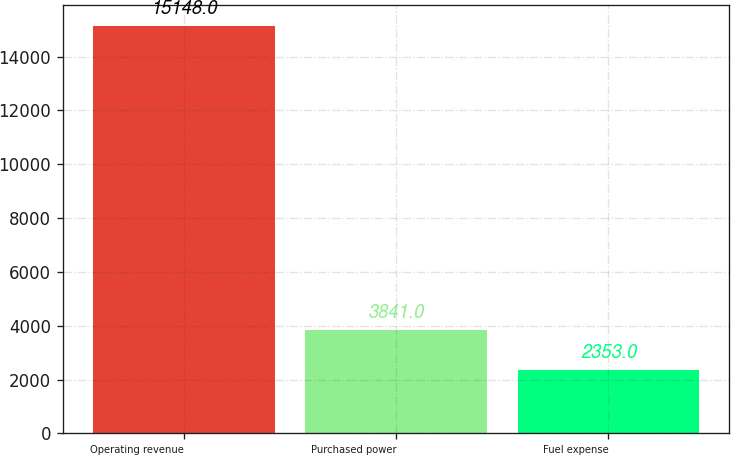Convert chart. <chart><loc_0><loc_0><loc_500><loc_500><bar_chart><fcel>Operating revenue<fcel>Purchased power<fcel>Fuel expense<nl><fcel>15148<fcel>3841<fcel>2353<nl></chart> 